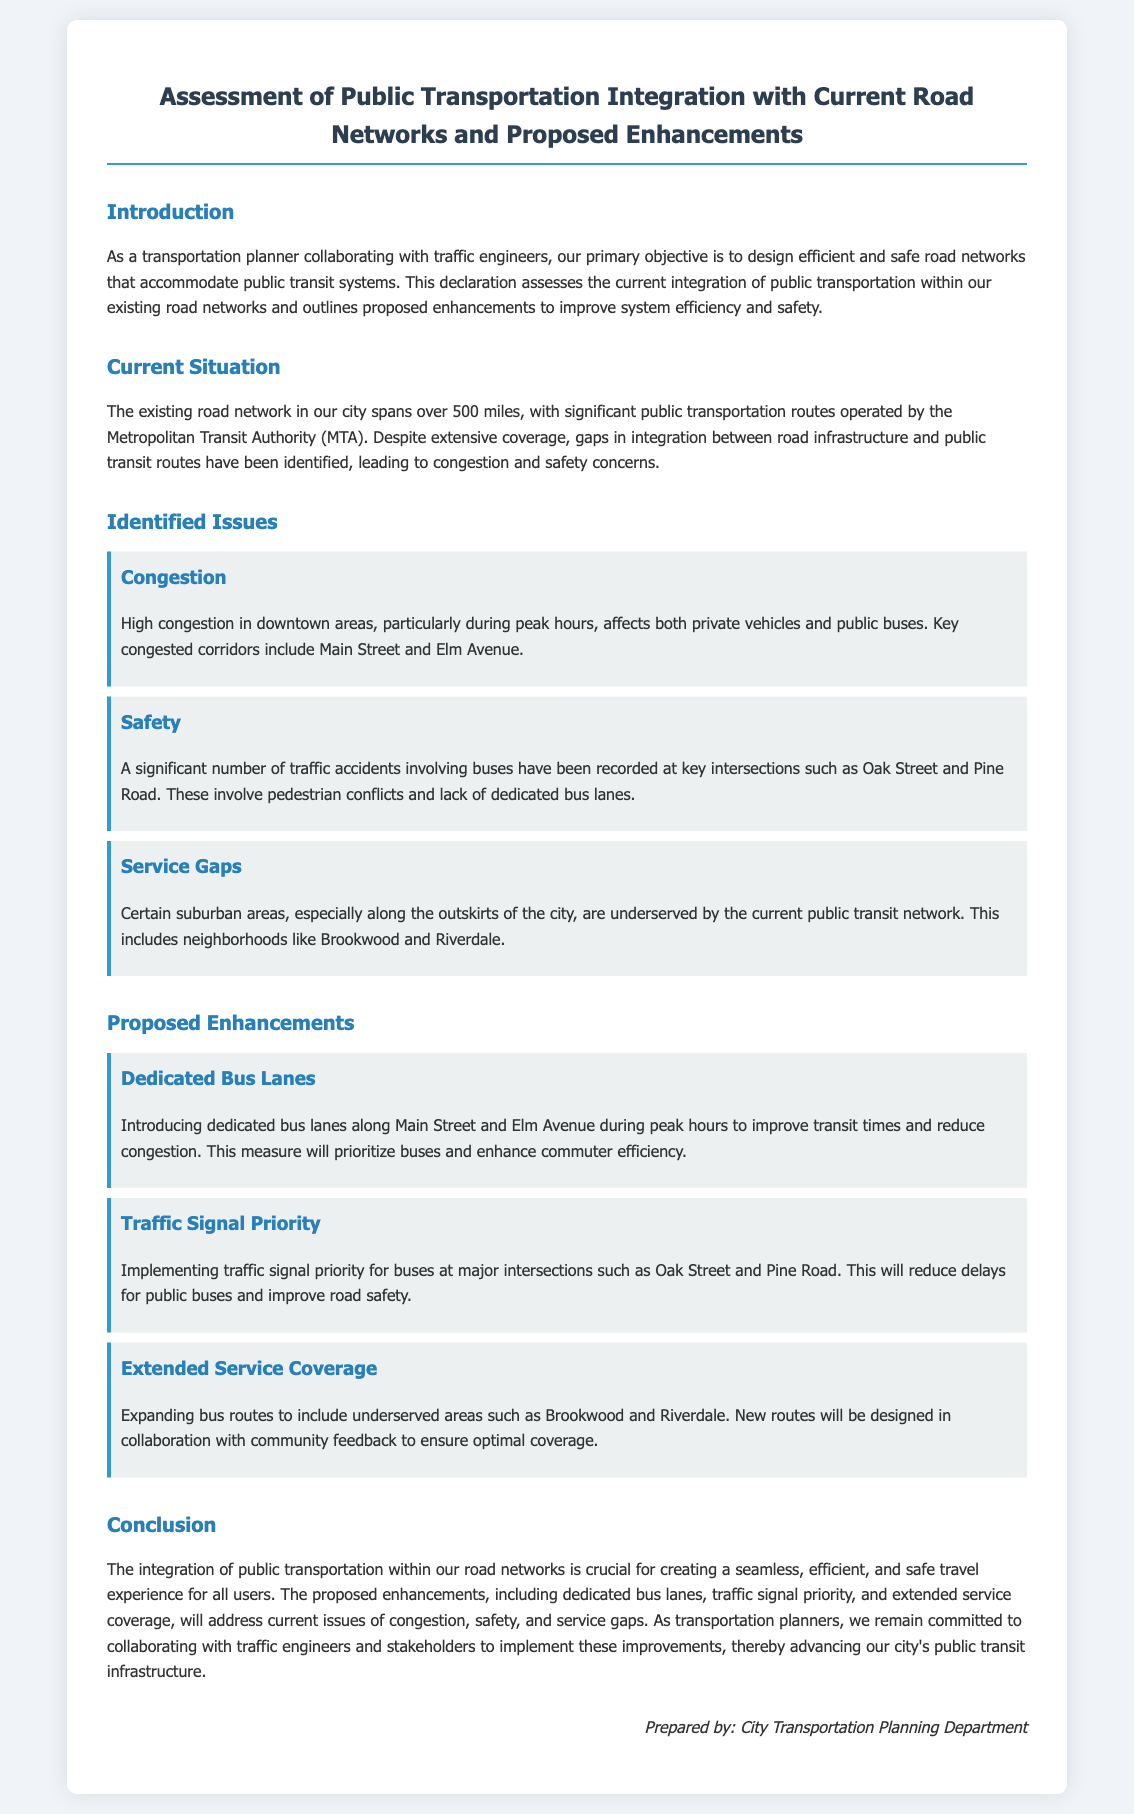what is the total length of the existing road network in the city? The total length of the existing road network is explicitly stated in the introduction section of the document.
Answer: 500 miles who operates the significant public transportation routes? The agency responsible for operating the public transportation routes is mentioned in the introduction section.
Answer: Metropolitan Transit Authority (MTA) what are the key congested corridors identified in the document? These corridors are specified in the identified issues section.
Answer: Main Street and Elm Avenue which intersections have recorded traffic accidents involving buses? The intersections with traffic accidents involving buses are noted in the issues section.
Answer: Oak Street and Pine Road what is one proposed enhancement to improve transit times? The enhancement aimed at improving transit times is detailed in the proposed enhancements section.
Answer: Dedicated Bus Lanes how will traffic signal priority enhance bus operations? This measure is explained in terms of its benefits for bus operations at major intersections in the enhancements section.
Answer: Reduce delays what underserved neighborhoods are mentioned for service coverage expansion? The neighborhoods that are noted as underserved are included in the proposed enhancements section.
Answer: Brookwood and Riverdale who prepared the document? The author of the declaration is stated in the sign-off section.
Answer: City Transportation Planning Department 